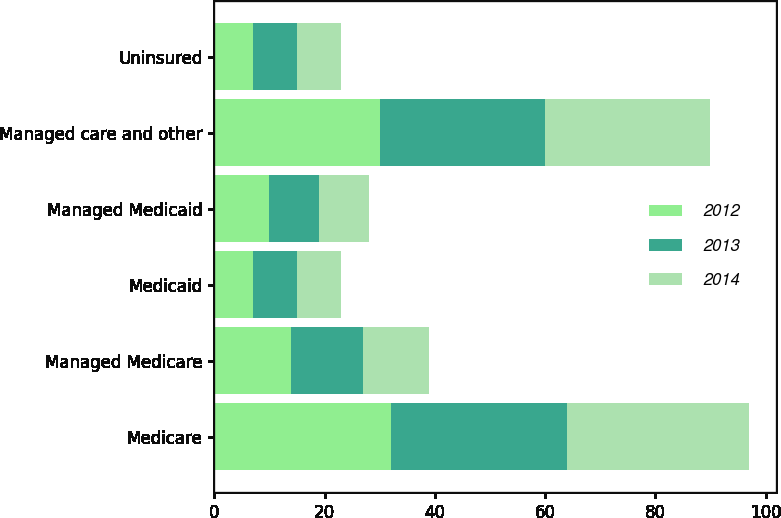Convert chart. <chart><loc_0><loc_0><loc_500><loc_500><stacked_bar_chart><ecel><fcel>Medicare<fcel>Managed Medicare<fcel>Medicaid<fcel>Managed Medicaid<fcel>Managed care and other<fcel>Uninsured<nl><fcel>2012<fcel>32<fcel>14<fcel>7<fcel>10<fcel>30<fcel>7<nl><fcel>2013<fcel>32<fcel>13<fcel>8<fcel>9<fcel>30<fcel>8<nl><fcel>2014<fcel>33<fcel>12<fcel>8<fcel>9<fcel>30<fcel>8<nl></chart> 